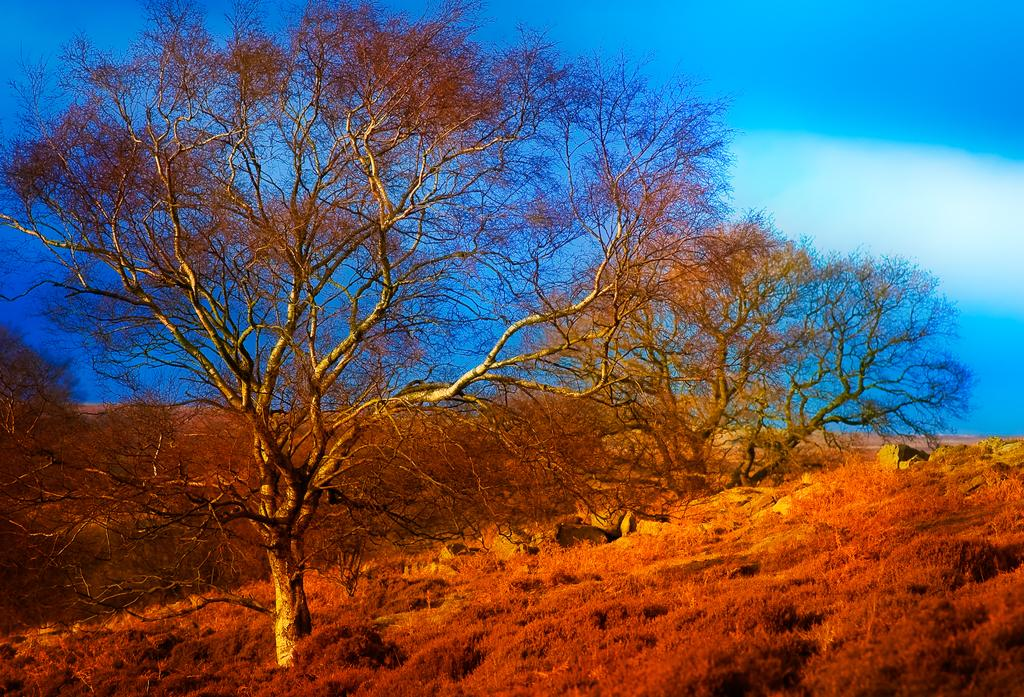What type of vegetation is present in the image? There are trees and grass in the image. What else can be seen on the ground in the image? There are rocks on the ground in the image. What is visible in the background of the image? The sky is visible in the background of the image. Can you hear the voice of the giraffe in the image? There is no giraffe present in the image, so it is not possible to hear its voice. What type of support is provided by the rocks in the image? The rocks in the image are not providing any visible support for other objects or structures. 